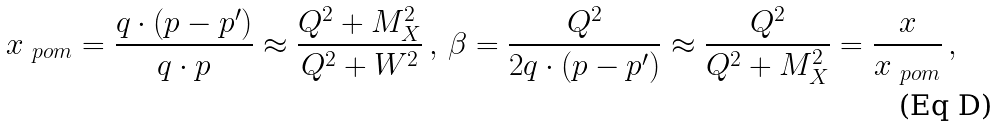Convert formula to latex. <formula><loc_0><loc_0><loc_500><loc_500>x _ { \ p o m } = \frac { q \cdot ( p - p ^ { \prime } ) } { q \cdot p } \approx \frac { Q ^ { 2 } + M _ { X } ^ { 2 } } { Q ^ { 2 } + W ^ { 2 } } \, , \, \beta = \frac { Q ^ { 2 } } { 2 q \cdot ( p - p ^ { \prime } ) } \approx \frac { Q ^ { 2 } } { Q ^ { 2 } + M _ { X } ^ { 2 } } = \frac { x } { x _ { \ p o m } } \, ,</formula> 